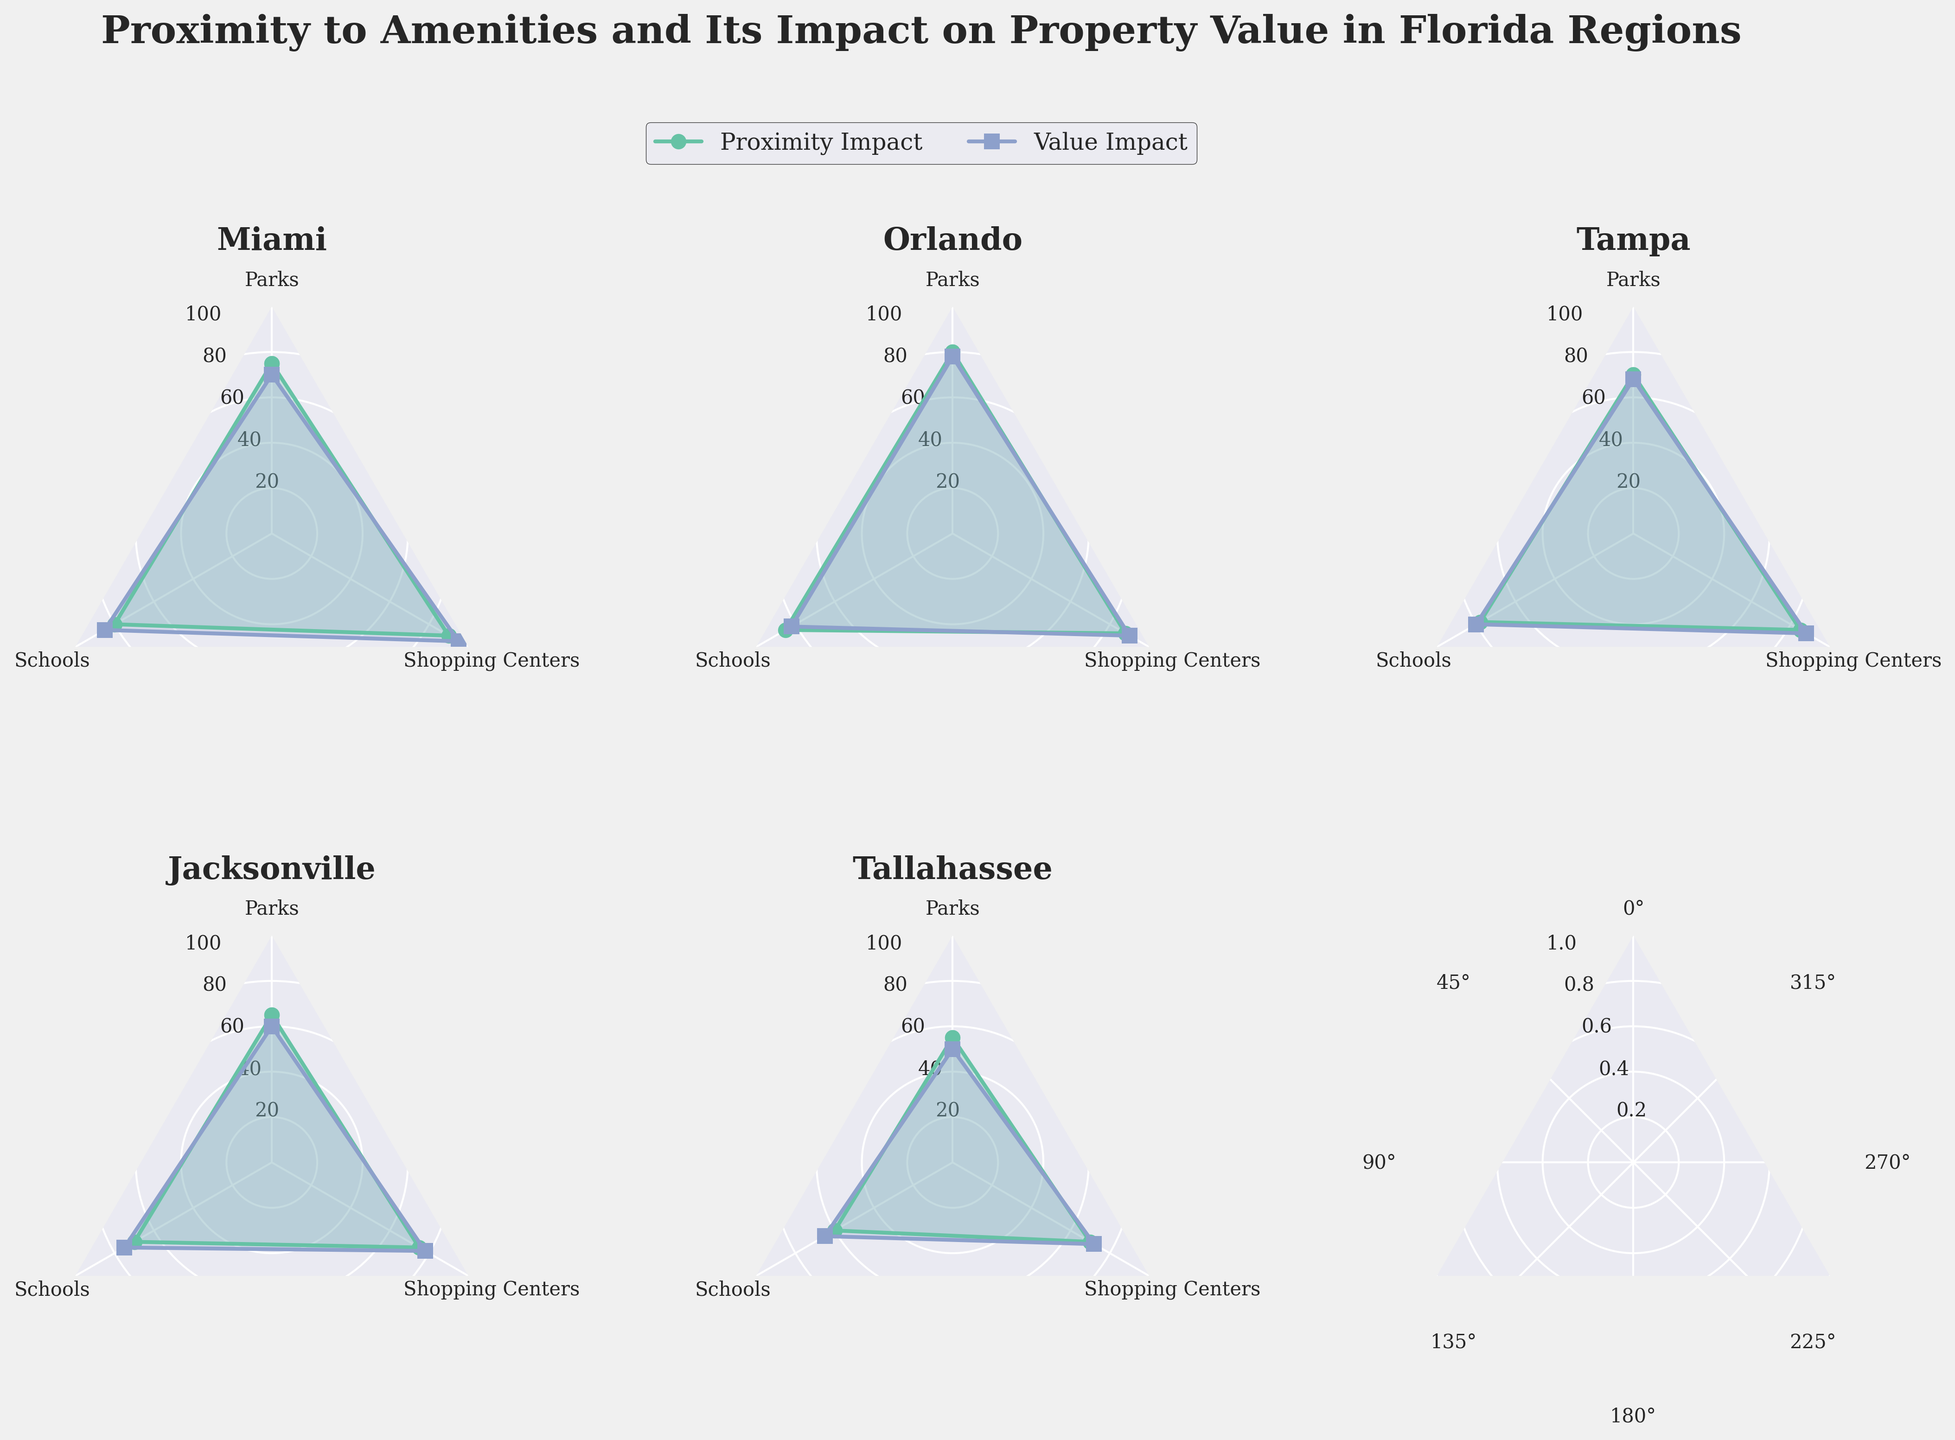Which region has the highest impact on property value from proximity to shopping centers? To find this, look at the radar chart and identify the region with the highest score in the "Property Value Impact" line related to "Shopping Centers". Miami has the highest score at 95.
Answer: Miami What is the difference in the impact of park proximity on property value between Orlando and Jacksonville? Check the "Property Value Impact" lines for parks for both regions. Orlando has a score of 78 and Jacksonville has 60. The difference is 78 - 60 = 18.
Answer: 18 Which region shows the least impact of proximity to schools on property value? Compare the scores for "Property Value Impact" for schools across all regions. Tallahassee has the lowest impact on property value at 65.
Answer: Tallahassee What are the three categories compared in the radar chart? By looking at the axes of the radar chart, the three categories being compared are Parks, Schools, and Shopping Centers.
Answer: Parks, Schools, Shopping Centers How does the impact of proximity to parks on property value in Tallahassee compare to Miami? Check the scores for "Property Value Impact" on parks for both regions. Tallahassee has a score of 50, and Miami has 70, so Miami has a higher impact.
Answer: Miami has a higher impact What is the average property value impact of shopping centers across all regions? Sum the "Property Value Impact" scores for shopping centers across all regions and divide by the number of regions. (95 + 90 + 88 + 78 + 72) / 5 = 84.6.
Answer: 84.6 Which two regions have the closest property value impact due to proximity to schools? Compare the "Property Value Impact" scores of schools for each region and find the closest values. Orlando (82) and Tampa (80) have the closest property value impacts.
Answer: Orlando and Tampa Are parks or schools generally more impactful on property value in Orlando? Compare the scores for "Property Value Impact" for parks and schools in Orlando. Schools have a score of 82 compared to 78 for parks, indicating schools are more impactful.
Answer: Schools What is the median impact of proximity to amenities on property value when considering shopping centers across all regions? First arrange the property value impact scores for shopping centers in ascending order: 72, 78, 88, 90, 95. The median, or middle value, is 88.
Answer: 88 